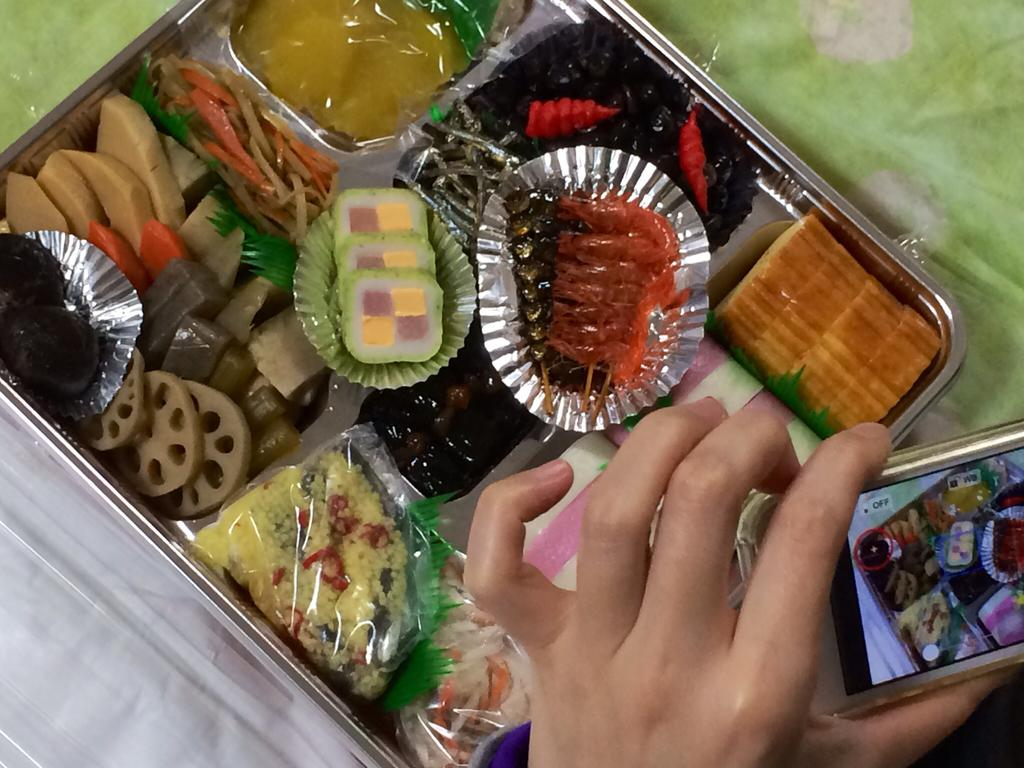What type of food is in the box in the image? There are sweets in a box in the image. Can you describe any body parts visible in the image? A person's hand is visible in the image. What type of device is present in the image? There is a camera in the image. Can you tell me how many snails are crawling on the sweets in the image? There are no snails present in the image. What type of comparison can be made between the sweets and the yam in the image? There is no yam present in the image, so no comparison can be made. 